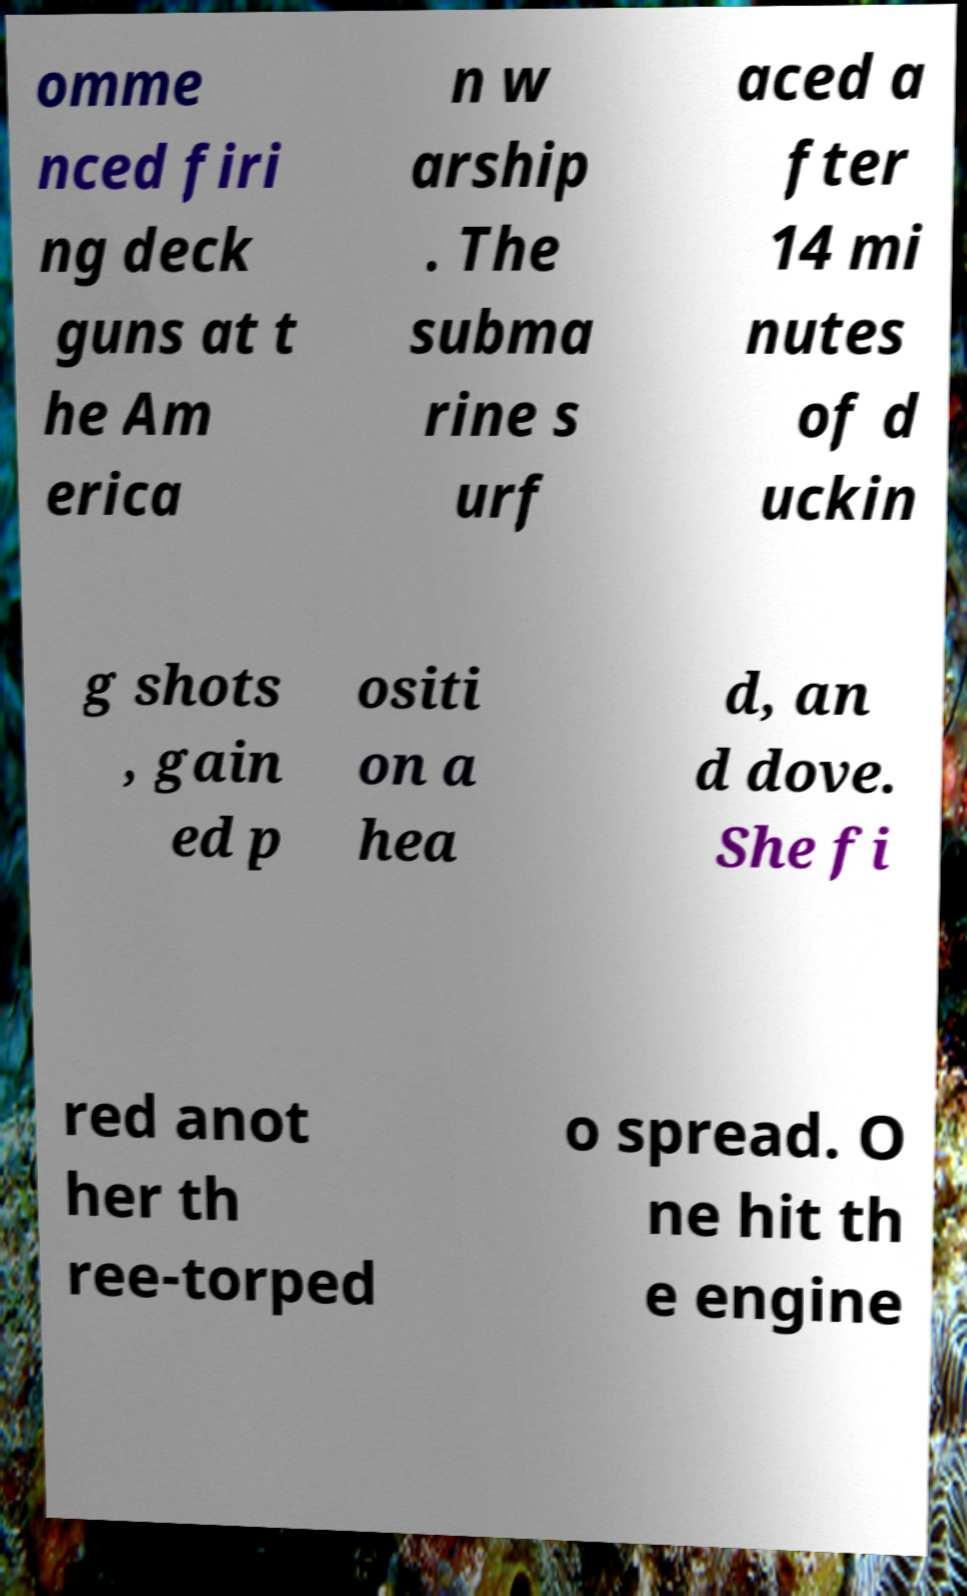Please read and relay the text visible in this image. What does it say? omme nced firi ng deck guns at t he Am erica n w arship . The subma rine s urf aced a fter 14 mi nutes of d uckin g shots , gain ed p ositi on a hea d, an d dove. She fi red anot her th ree-torped o spread. O ne hit th e engine 